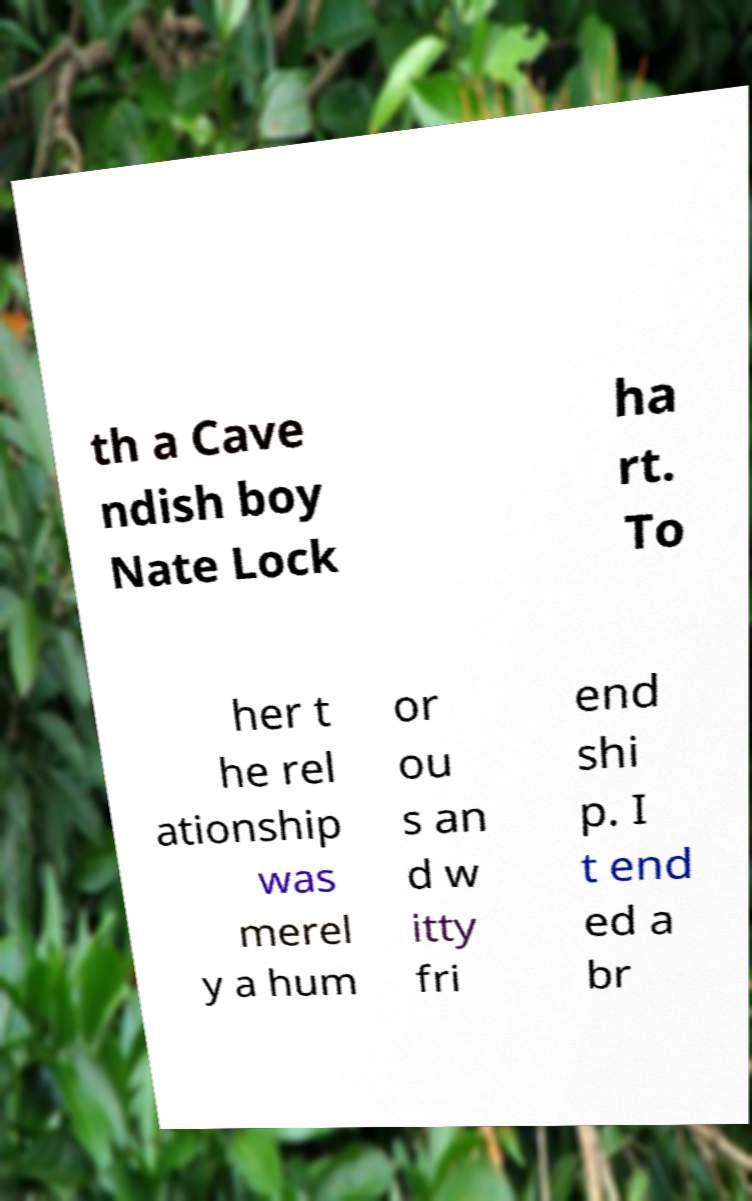What messages or text are displayed in this image? I need them in a readable, typed format. th a Cave ndish boy Nate Lock ha rt. To her t he rel ationship was merel y a hum or ou s an d w itty fri end shi p. I t end ed a br 